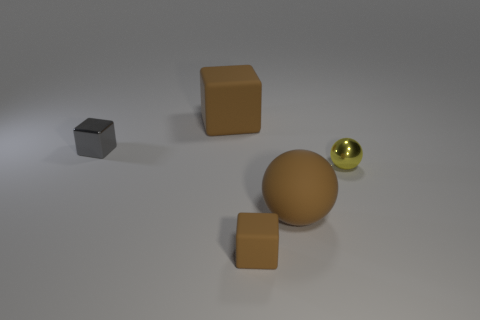Subtract all brown spheres. How many brown blocks are left? 2 Subtract all big brown blocks. How many blocks are left? 2 Subtract 1 blocks. How many blocks are left? 2 Add 1 tiny rubber blocks. How many objects exist? 6 Subtract all cubes. How many objects are left? 2 Add 5 large things. How many large things are left? 7 Add 3 tiny yellow metallic things. How many tiny yellow metallic things exist? 4 Subtract 0 yellow cylinders. How many objects are left? 5 Subtract all large brown things. Subtract all big rubber things. How many objects are left? 1 